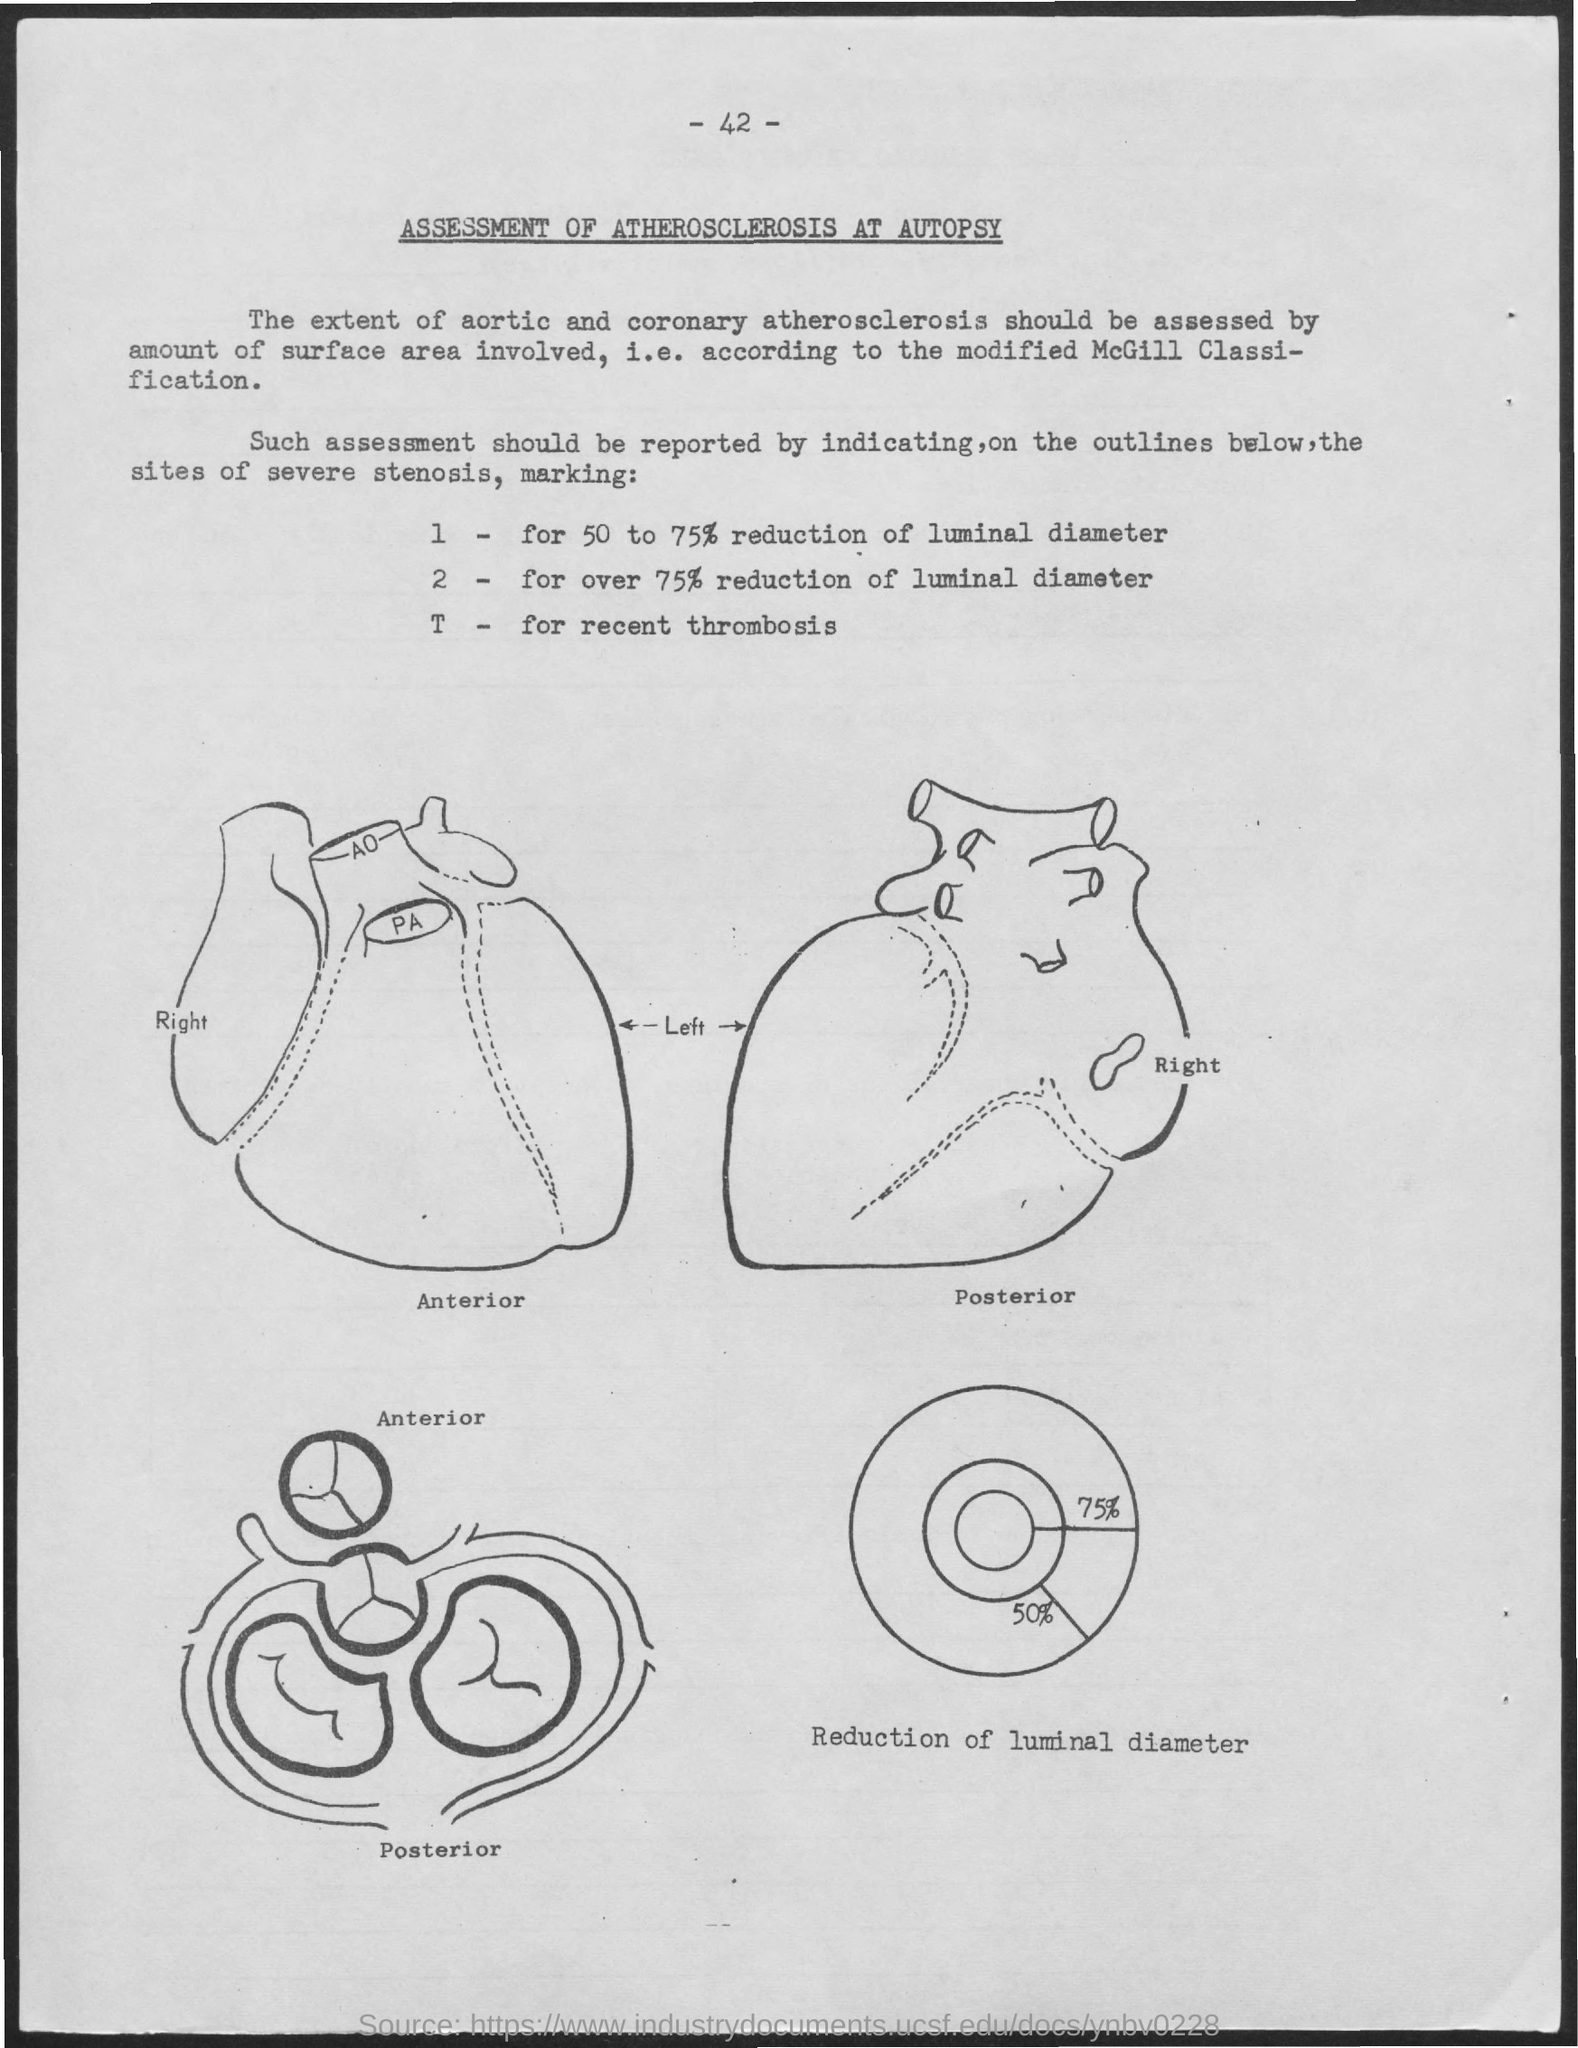List a handful of essential elements in this visual. The title of the document is 'Assessment of Atherosclerosis at Autopsy.' The page number is 42, as stated. 